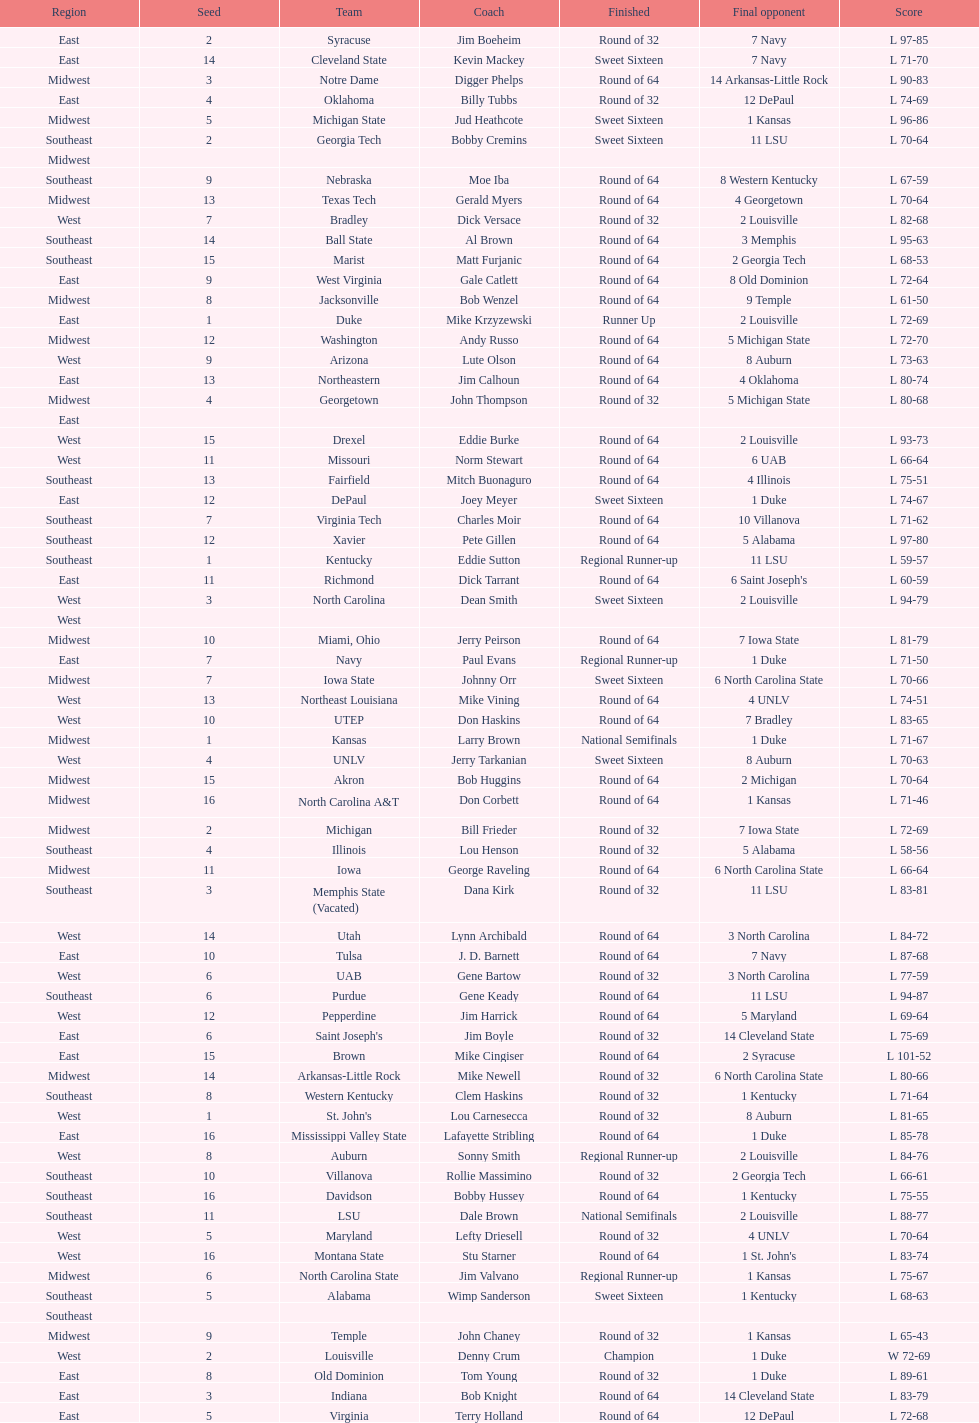What's the total count of teams in the east region? 16. 